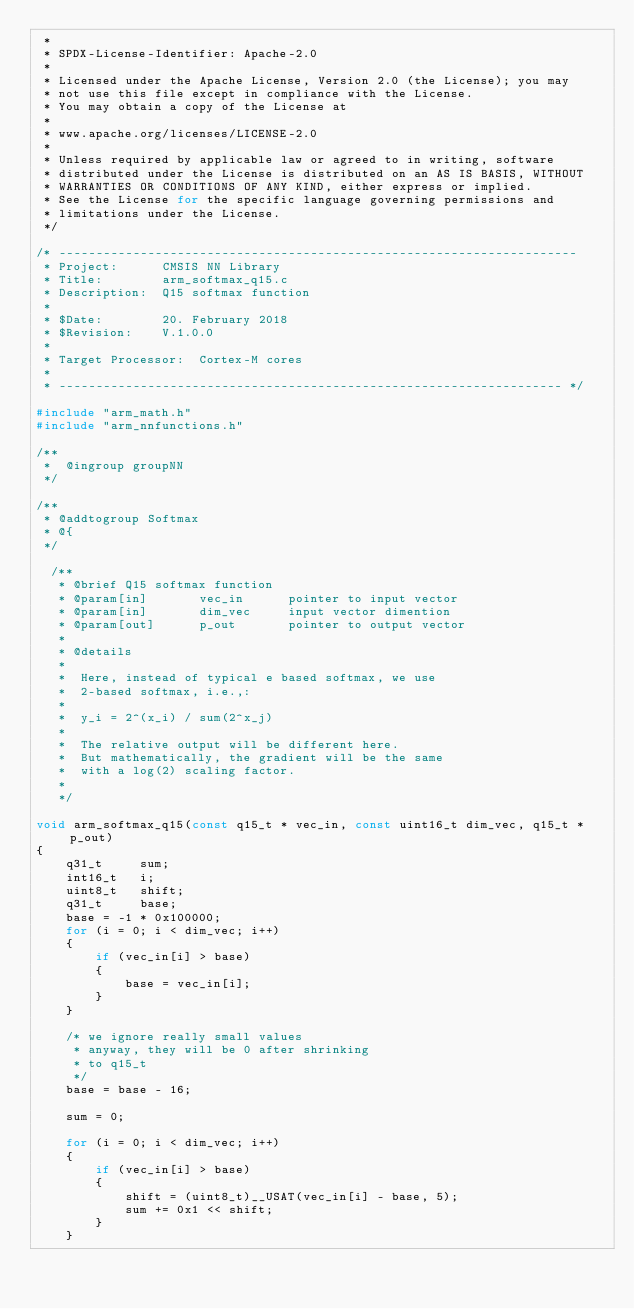Convert code to text. <code><loc_0><loc_0><loc_500><loc_500><_C_> *
 * SPDX-License-Identifier: Apache-2.0
 *
 * Licensed under the Apache License, Version 2.0 (the License); you may
 * not use this file except in compliance with the License.
 * You may obtain a copy of the License at
 *
 * www.apache.org/licenses/LICENSE-2.0
 *
 * Unless required by applicable law or agreed to in writing, software
 * distributed under the License is distributed on an AS IS BASIS, WITHOUT
 * WARRANTIES OR CONDITIONS OF ANY KIND, either express or implied.
 * See the License for the specific language governing permissions and
 * limitations under the License.
 */

/* ----------------------------------------------------------------------
 * Project:      CMSIS NN Library
 * Title:        arm_softmax_q15.c
 * Description:  Q15 softmax function
 *
 * $Date:        20. February 2018
 * $Revision:    V.1.0.0
 *
 * Target Processor:  Cortex-M cores
 *
 * -------------------------------------------------------------------- */

#include "arm_math.h"
#include "arm_nnfunctions.h"

/**
 *  @ingroup groupNN
 */

/**
 * @addtogroup Softmax
 * @{
 */

  /**
   * @brief Q15 softmax function
   * @param[in]       vec_in      pointer to input vector
   * @param[in]       dim_vec     input vector dimention
   * @param[out]      p_out       pointer to output vector
   *
   * @details
   *
   *  Here, instead of typical e based softmax, we use
   *  2-based softmax, i.e.,:
   *
   *  y_i = 2^(x_i) / sum(2^x_j)
   *
   *  The relative output will be different here.
   *  But mathematically, the gradient will be the same
   *  with a log(2) scaling factor.
   *
   */

void arm_softmax_q15(const q15_t * vec_in, const uint16_t dim_vec, q15_t * p_out)
{
    q31_t     sum;
    int16_t   i;
    uint8_t   shift;
    q31_t     base;
    base = -1 * 0x100000;
    for (i = 0; i < dim_vec; i++)
    {
        if (vec_in[i] > base)
        {
            base = vec_in[i];
        }
    }

    /* we ignore really small values
     * anyway, they will be 0 after shrinking
     * to q15_t
     */
    base = base - 16;

    sum = 0;

    for (i = 0; i < dim_vec; i++)
    {
        if (vec_in[i] > base)
        {
            shift = (uint8_t)__USAT(vec_in[i] - base, 5);
            sum += 0x1 << shift;
        }
    }
</code> 